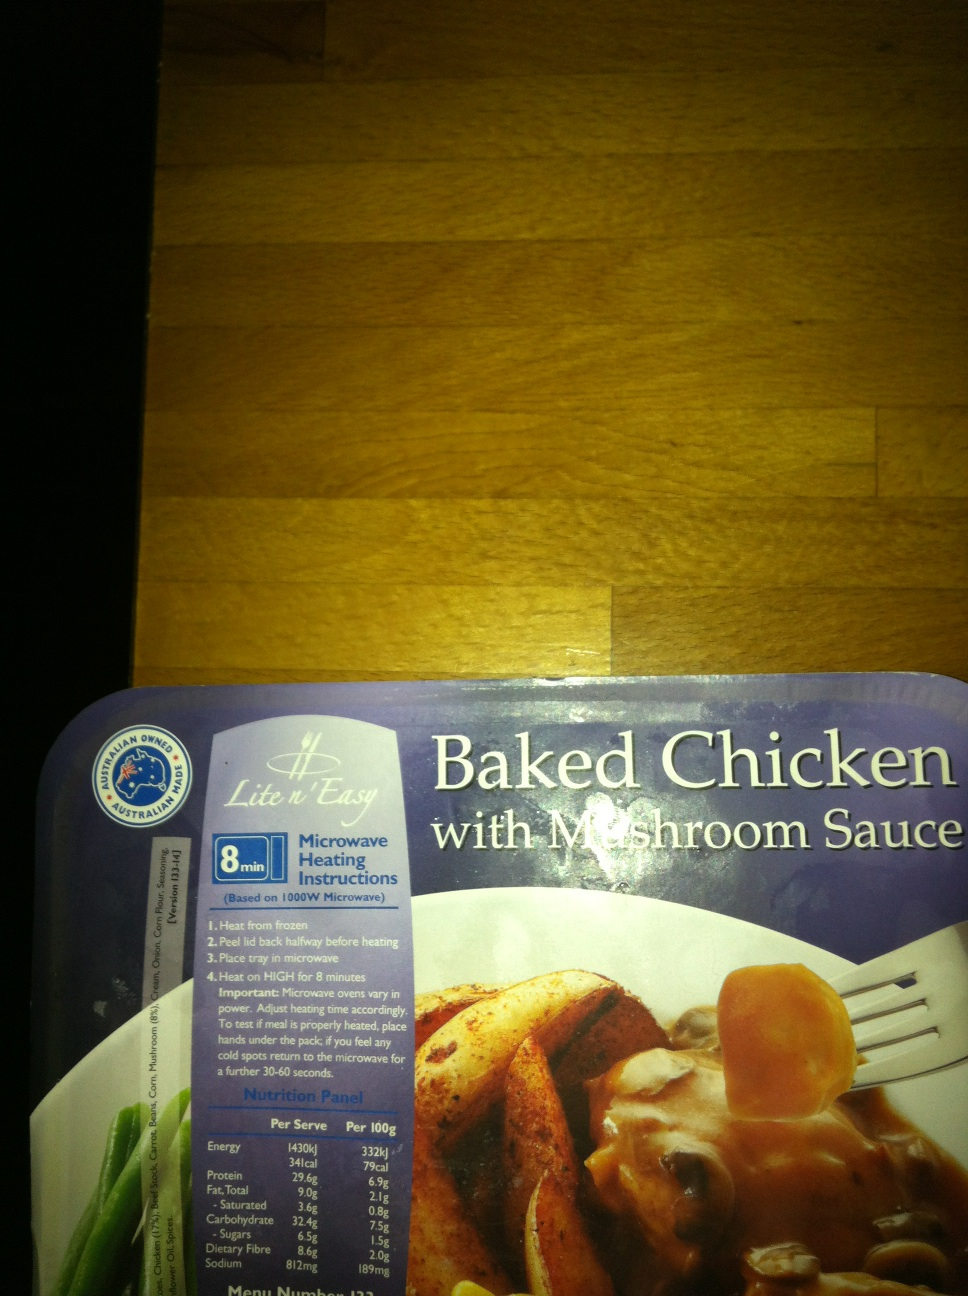What is in this box? The box contains a ready-to-cook meal specifically, 'Baked Chicken with Mushroom Sauce' as detailed on the packaging. It also includes microwave heating instructions and a nutrition panel, indicating it's designed for quick and convenient meal preparation. Ideal for those seeking a fast, tasty, and easy meal option. 